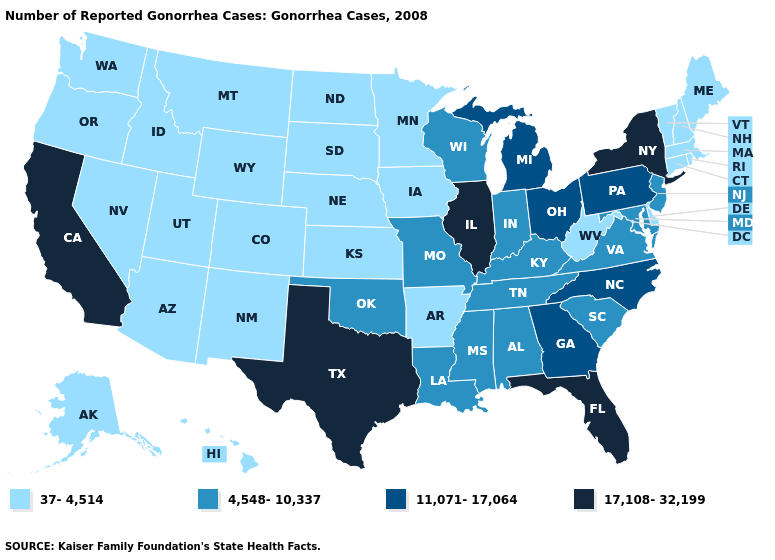Name the states that have a value in the range 11,071-17,064?
Concise answer only. Georgia, Michigan, North Carolina, Ohio, Pennsylvania. Which states hav the highest value in the MidWest?
Write a very short answer. Illinois. Name the states that have a value in the range 4,548-10,337?
Concise answer only. Alabama, Indiana, Kentucky, Louisiana, Maryland, Mississippi, Missouri, New Jersey, Oklahoma, South Carolina, Tennessee, Virginia, Wisconsin. Which states have the lowest value in the USA?
Keep it brief. Alaska, Arizona, Arkansas, Colorado, Connecticut, Delaware, Hawaii, Idaho, Iowa, Kansas, Maine, Massachusetts, Minnesota, Montana, Nebraska, Nevada, New Hampshire, New Mexico, North Dakota, Oregon, Rhode Island, South Dakota, Utah, Vermont, Washington, West Virginia, Wyoming. Name the states that have a value in the range 17,108-32,199?
Write a very short answer. California, Florida, Illinois, New York, Texas. What is the value of Pennsylvania?
Give a very brief answer. 11,071-17,064. Does Arizona have the same value as Virginia?
Concise answer only. No. Which states have the highest value in the USA?
Answer briefly. California, Florida, Illinois, New York, Texas. Name the states that have a value in the range 37-4,514?
Be succinct. Alaska, Arizona, Arkansas, Colorado, Connecticut, Delaware, Hawaii, Idaho, Iowa, Kansas, Maine, Massachusetts, Minnesota, Montana, Nebraska, Nevada, New Hampshire, New Mexico, North Dakota, Oregon, Rhode Island, South Dakota, Utah, Vermont, Washington, West Virginia, Wyoming. What is the value of Washington?
Answer briefly. 37-4,514. Name the states that have a value in the range 37-4,514?
Give a very brief answer. Alaska, Arizona, Arkansas, Colorado, Connecticut, Delaware, Hawaii, Idaho, Iowa, Kansas, Maine, Massachusetts, Minnesota, Montana, Nebraska, Nevada, New Hampshire, New Mexico, North Dakota, Oregon, Rhode Island, South Dakota, Utah, Vermont, Washington, West Virginia, Wyoming. What is the value of New Jersey?
Answer briefly. 4,548-10,337. Which states have the lowest value in the USA?
Keep it brief. Alaska, Arizona, Arkansas, Colorado, Connecticut, Delaware, Hawaii, Idaho, Iowa, Kansas, Maine, Massachusetts, Minnesota, Montana, Nebraska, Nevada, New Hampshire, New Mexico, North Dakota, Oregon, Rhode Island, South Dakota, Utah, Vermont, Washington, West Virginia, Wyoming. What is the lowest value in the USA?
Keep it brief. 37-4,514. Name the states that have a value in the range 4,548-10,337?
Answer briefly. Alabama, Indiana, Kentucky, Louisiana, Maryland, Mississippi, Missouri, New Jersey, Oklahoma, South Carolina, Tennessee, Virginia, Wisconsin. 